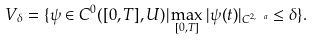<formula> <loc_0><loc_0><loc_500><loc_500>V _ { \delta } = \{ \psi \in C ^ { 0 } ( [ 0 , T ] , U ) | \max _ { [ 0 , T ] } | \psi ( t ) | _ { C ^ { 2 , \ a } } \leq \delta \} .</formula> 